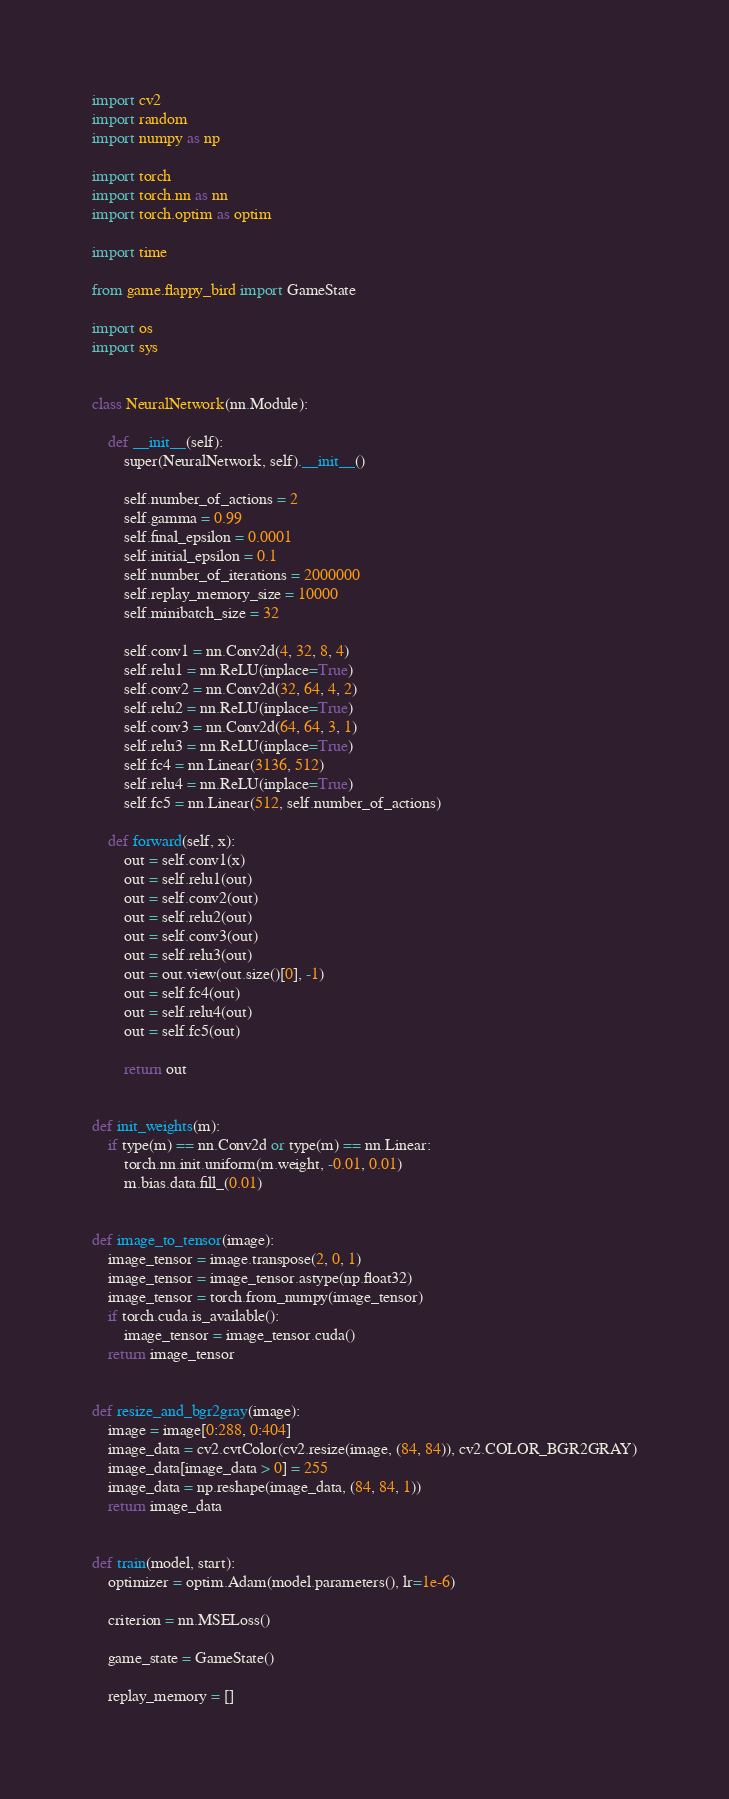<code> <loc_0><loc_0><loc_500><loc_500><_Python_>import cv2
import random
import numpy as np

import torch
import torch.nn as nn
import torch.optim as optim

import time

from game.flappy_bird import GameState

import os
import sys


class NeuralNetwork(nn.Module):

    def __init__(self):
        super(NeuralNetwork, self).__init__()

        self.number_of_actions = 2
        self.gamma = 0.99
        self.final_epsilon = 0.0001
        self.initial_epsilon = 0.1
        self.number_of_iterations = 2000000
        self.replay_memory_size = 10000
        self.minibatch_size = 32

        self.conv1 = nn.Conv2d(4, 32, 8, 4)
        self.relu1 = nn.ReLU(inplace=True)
        self.conv2 = nn.Conv2d(32, 64, 4, 2)
        self.relu2 = nn.ReLU(inplace=True)
        self.conv3 = nn.Conv2d(64, 64, 3, 1)
        self.relu3 = nn.ReLU(inplace=True)
        self.fc4 = nn.Linear(3136, 512)
        self.relu4 = nn.ReLU(inplace=True)
        self.fc5 = nn.Linear(512, self.number_of_actions)

    def forward(self, x):
        out = self.conv1(x)
        out = self.relu1(out)
        out = self.conv2(out)
        out = self.relu2(out)
        out = self.conv3(out)
        out = self.relu3(out)
        out = out.view(out.size()[0], -1)
        out = self.fc4(out)
        out = self.relu4(out)
        out = self.fc5(out)

        return out


def init_weights(m):
    if type(m) == nn.Conv2d or type(m) == nn.Linear:
        torch.nn.init.uniform(m.weight, -0.01, 0.01)
        m.bias.data.fill_(0.01)


def image_to_tensor(image):
    image_tensor = image.transpose(2, 0, 1)
    image_tensor = image_tensor.astype(np.float32)
    image_tensor = torch.from_numpy(image_tensor)
    if torch.cuda.is_available():
        image_tensor = image_tensor.cuda()
    return image_tensor


def resize_and_bgr2gray(image):
    image = image[0:288, 0:404]
    image_data = cv2.cvtColor(cv2.resize(image, (84, 84)), cv2.COLOR_BGR2GRAY)
    image_data[image_data > 0] = 255
    image_data = np.reshape(image_data, (84, 84, 1))
    return image_data


def train(model, start):
    optimizer = optim.Adam(model.parameters(), lr=1e-6)

    criterion = nn.MSELoss()

    game_state = GameState()

    replay_memory = []
</code> 